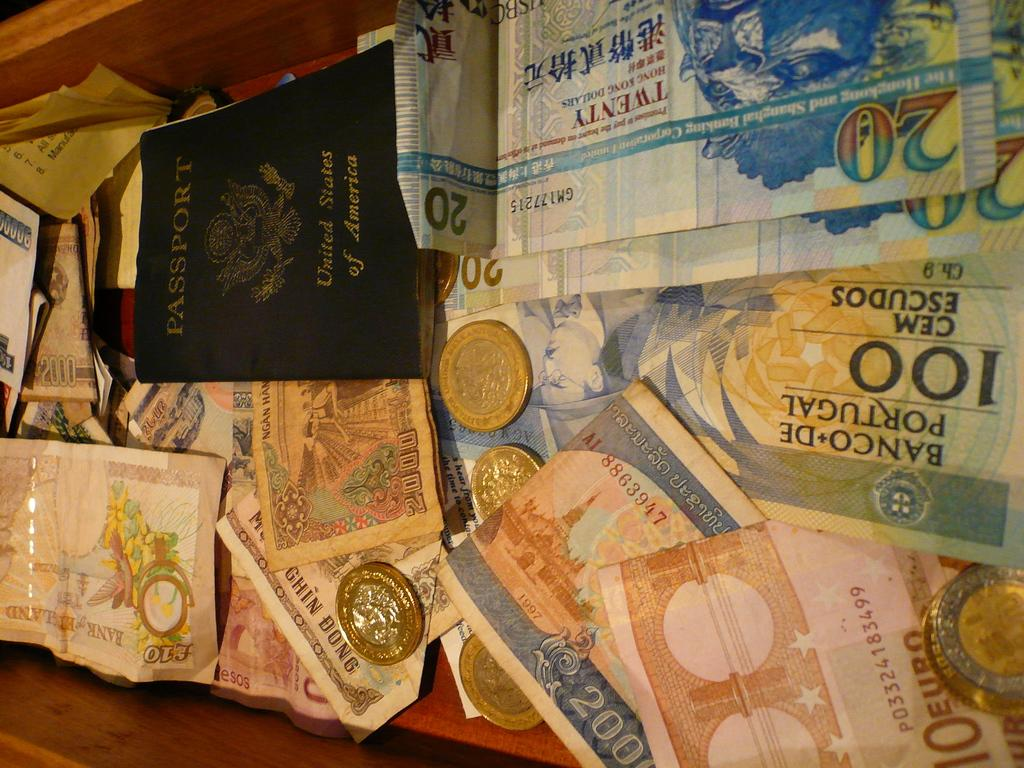<image>
Present a compact description of the photo's key features. A bunch of money sitting in a draw that has a United States passport in it. 